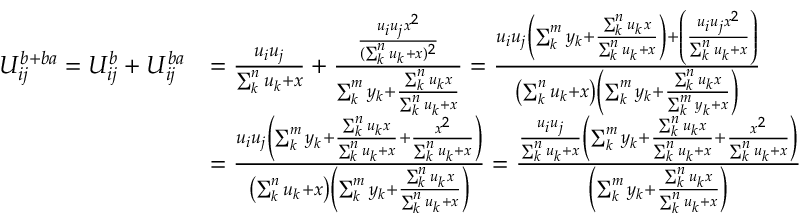Convert formula to latex. <formula><loc_0><loc_0><loc_500><loc_500>\begin{array} { r l } { U _ { i j } ^ { b + b a } = U _ { i j } ^ { b } + U _ { i j } ^ { b a } } & { = \frac { u _ { i } u _ { j } } { \sum _ { k } ^ { n } u _ { k } + x } + \frac { \frac { u _ { i } u _ { j } x ^ { 2 } } { ( \sum _ { k } ^ { n } u _ { k } + x ) ^ { 2 } } } { \sum _ { k } ^ { m } y _ { k } + \frac { \sum _ { k } ^ { n } u _ { k } x } { \sum _ { k } ^ { n } u _ { k } + x } } = \frac { u _ { i } u _ { j } \left ( \sum _ { k } ^ { m } y _ { k } + \frac { \sum _ { k } ^ { n } u _ { k } x } { \sum _ { k } ^ { n } u _ { k } + x } \right ) + \left ( \frac { u _ { i } u _ { j } x ^ { 2 } } { \sum _ { k } ^ { n } u _ { k } + x } \right ) } { \left ( \sum _ { k } ^ { n } u _ { k } + x \right ) \left ( \sum _ { k } ^ { m } y _ { k } + \frac { \sum _ { k } ^ { n } u _ { k } x } { \sum _ { k } ^ { m } y _ { k } + x } \right ) } } \\ & { = \frac { u _ { i } u _ { j } \left ( \sum _ { k } ^ { m } y _ { k } + \frac { \sum _ { k } ^ { n } u _ { k } x } { \sum _ { k } ^ { n } u _ { k } + x } + \frac { x ^ { 2 } } { \sum _ { k } ^ { n } u _ { k } + x } \right ) } { \left ( \sum _ { k } ^ { n } u _ { k } + x \right ) \left ( \sum _ { k } ^ { m } y _ { k } + \frac { \sum _ { k } ^ { n } u _ { k } x } { \sum _ { k } ^ { n } u _ { k } + x } \right ) } = \frac { \frac { u _ { i } u _ { j } } { \sum _ { k } ^ { n } u _ { k } + x } \left ( \sum _ { k } ^ { m } y _ { k } + \frac { \sum _ { k } ^ { n } u _ { k } x } { \sum _ { k } ^ { n } u _ { k } + x } + \frac { x ^ { 2 } } { \sum _ { k } ^ { n } u _ { k } + x } \right ) } { \left ( \sum _ { k } ^ { m } y _ { k } + \frac { \sum _ { k } ^ { n } u _ { k } x } { \sum _ { k } ^ { n } u _ { k } + x } \right ) } } \end{array}</formula> 